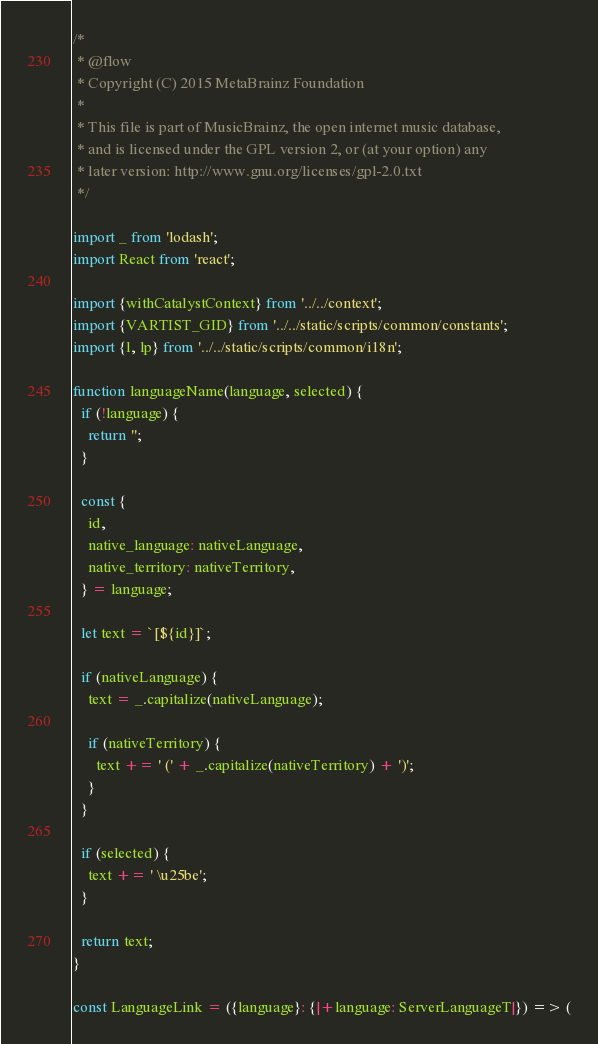Convert code to text. <code><loc_0><loc_0><loc_500><loc_500><_JavaScript_>/*
 * @flow
 * Copyright (C) 2015 MetaBrainz Foundation
 *
 * This file is part of MusicBrainz, the open internet music database,
 * and is licensed under the GPL version 2, or (at your option) any
 * later version: http://www.gnu.org/licenses/gpl-2.0.txt
 */

import _ from 'lodash';
import React from 'react';

import {withCatalystContext} from '../../context';
import {VARTIST_GID} from '../../static/scripts/common/constants';
import {l, lp} from '../../static/scripts/common/i18n';

function languageName(language, selected) {
  if (!language) {
    return '';
  }

  const {
    id,
    native_language: nativeLanguage,
    native_territory: nativeTerritory,
  } = language;

  let text = `[${id}]`;

  if (nativeLanguage) {
    text = _.capitalize(nativeLanguage);

    if (nativeTerritory) {
      text += ' (' + _.capitalize(nativeTerritory) + ')';
    }
  }

  if (selected) {
    text += ' \u25be';
  }

  return text;
}

const LanguageLink = ({language}: {|+language: ServerLanguageT|}) => (</code> 